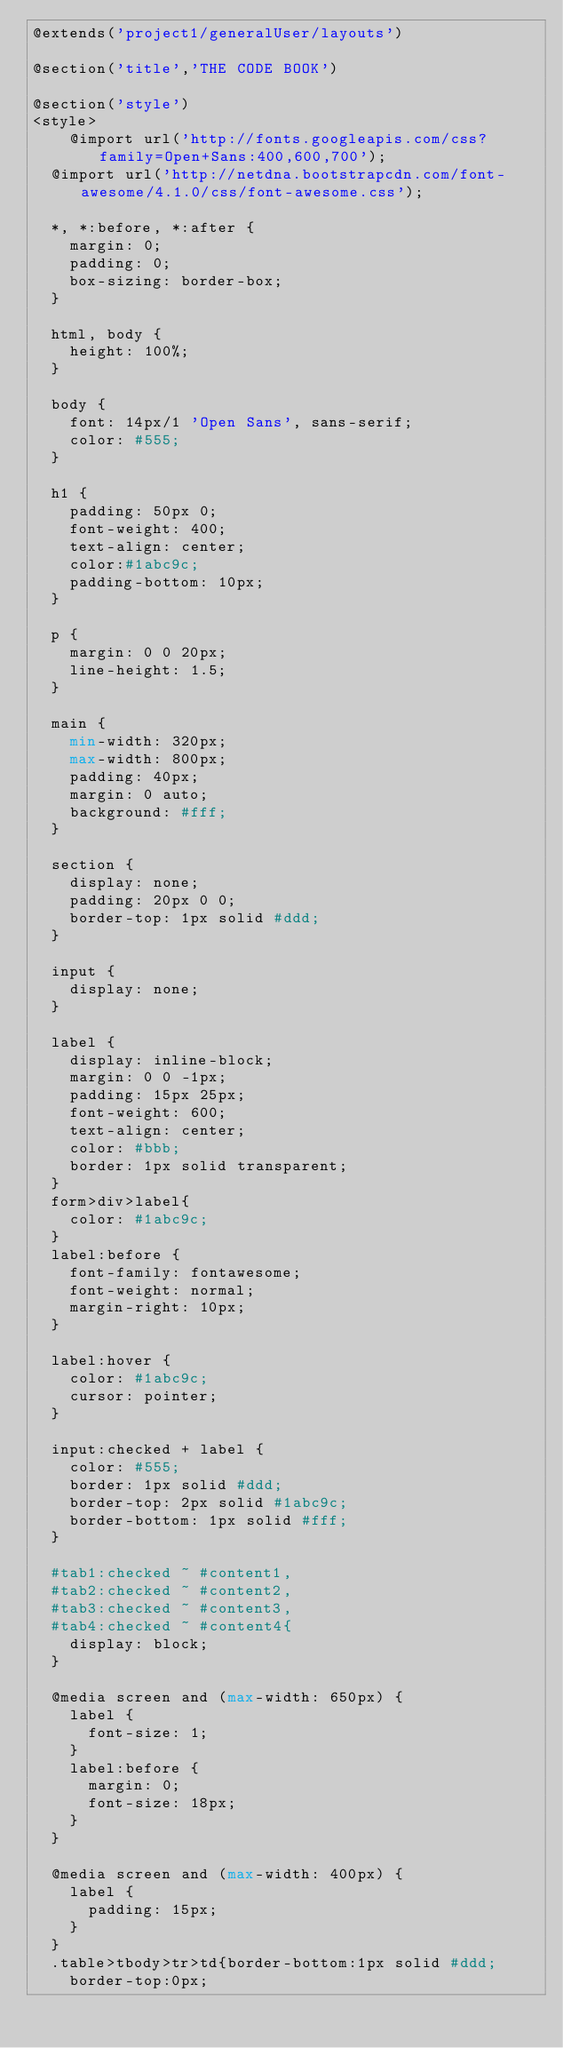<code> <loc_0><loc_0><loc_500><loc_500><_PHP_>@extends('project1/generalUser/layouts')

@section('title','THE CODE BOOK')

@section('style')
<style>
	@import url('http://fonts.googleapis.com/css?family=Open+Sans:400,600,700');
  @import url('http://netdna.bootstrapcdn.com/font-awesome/4.1.0/css/font-awesome.css');

  *, *:before, *:after {
    margin: 0;
    padding: 0;
    box-sizing: border-box;
  }

  html, body {
    height: 100%;
  }

  body {
    font: 14px/1 'Open Sans', sans-serif;
    color: #555;
  }

  h1 {
    padding: 50px 0;
    font-weight: 400;
    text-align: center;
    color:#1abc9c;
    padding-bottom: 10px;
  }

  p {
    margin: 0 0 20px;
    line-height: 1.5;
  }

  main {
    min-width: 320px;
    max-width: 800px;
    padding: 40px;
    margin: 0 auto;
    background: #fff;
  }

  section {
    display: none;
    padding: 20px 0 0;
    border-top: 1px solid #ddd;
  }

  input {
    display: none;
  }

  label {
    display: inline-block;
    margin: 0 0 -1px;
    padding: 15px 25px;
    font-weight: 600;
    text-align: center;
    color: #bbb;
    border: 1px solid transparent;
  }
  form>div>label{
    color: #1abc9c;
  }
  label:before {
    font-family: fontawesome;
    font-weight: normal;
    margin-right: 10px;
  }

  label:hover {
    color: #1abc9c;
    cursor: pointer;
  }

  input:checked + label {
    color: #555;
    border: 1px solid #ddd;
    border-top: 2px solid #1abc9c;
    border-bottom: 1px solid #fff;
  }

  #tab1:checked ~ #content1,
  #tab2:checked ~ #content2,
  #tab3:checked ~ #content3,
  #tab4:checked ~ #content4{
    display: block;
  }

  @media screen and (max-width: 650px) {
    label {
      font-size: 1;
    }
    label:before {
      margin: 0;
      font-size: 18px;
    }
  }

  @media screen and (max-width: 400px) {
    label {
      padding: 15px;
    }
  }
  .table>tbody>tr>td{border-bottom:1px solid #ddd;
    border-top:0px;
</code> 